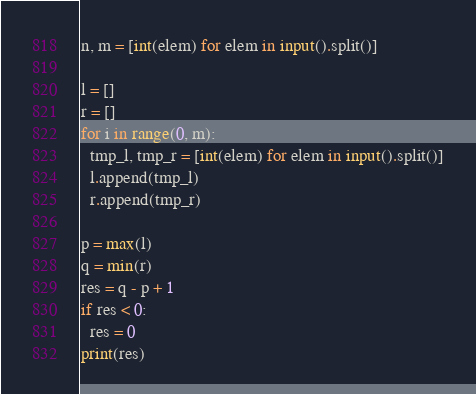Convert code to text. <code><loc_0><loc_0><loc_500><loc_500><_Python_>n, m = [int(elem) for elem in input().split()]

l = []
r = []
for i in range(0, m):
  tmp_l, tmp_r = [int(elem) for elem in input().split()]
  l.append(tmp_l)
  r.append(tmp_r)

p = max(l)
q = min(r)
res = q - p + 1
if res < 0:
  res = 0
print(res)</code> 